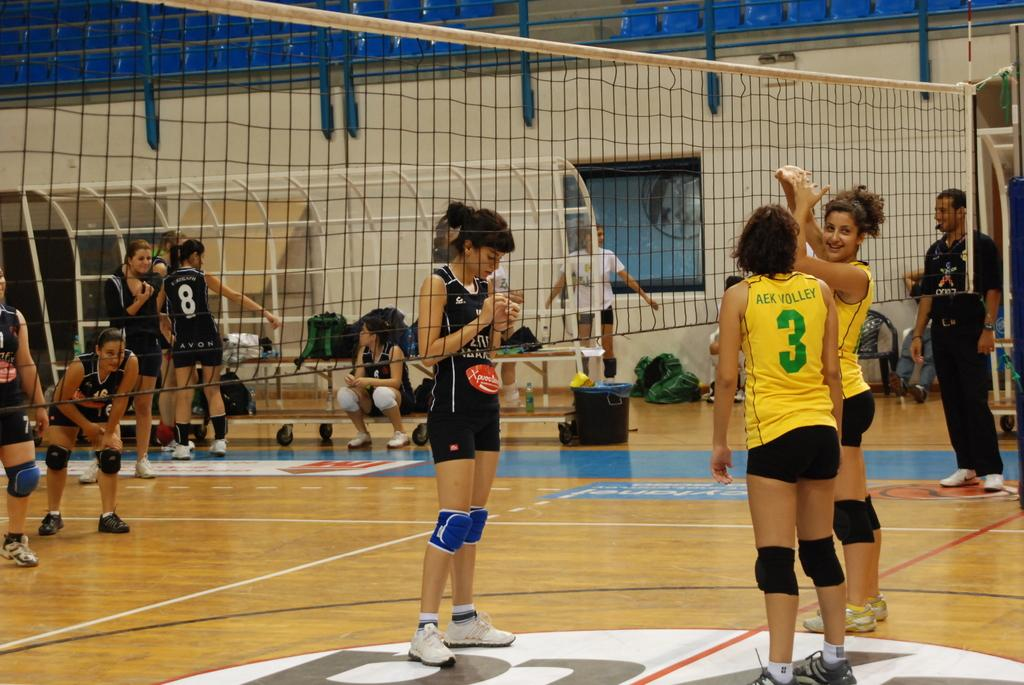<image>
Provide a brief description of the given image. A female volleyball player wearing the number 3 turns to her teammate on the court. 